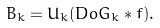<formula> <loc_0><loc_0><loc_500><loc_500>B _ { k } = U _ { k } ( D o G _ { k } * f ) .</formula> 